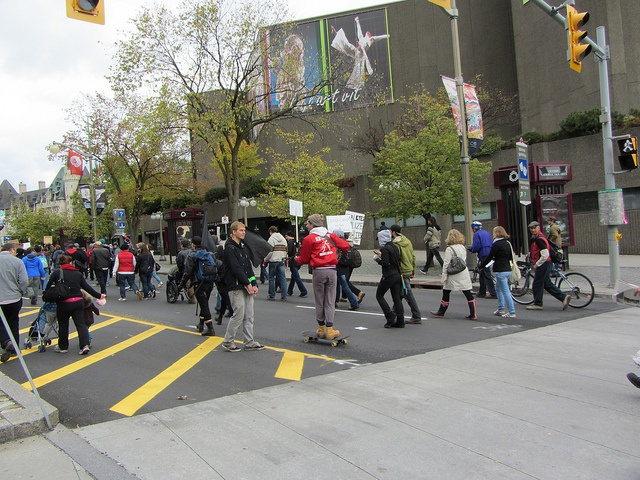Describe the objects in this image and their specific colors. I can see people in white, black, gray, darkgray, and navy tones, people in white, black, gray, maroon, and darkgray tones, people in white, gray, brown, maroon, and black tones, people in white, black, gray, and darkgray tones, and people in white, gray, darkgray, black, and lightgray tones in this image. 